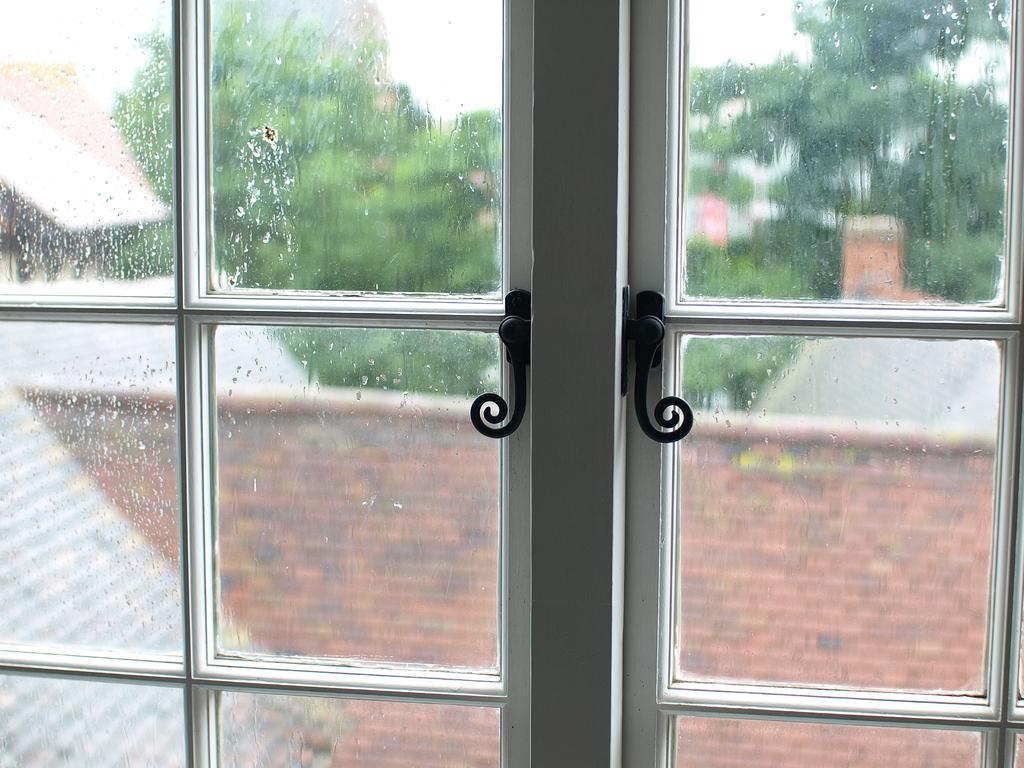Please provide a concise description of this image. In the center of the image there is a door and we can see trees, buildings and sky through the glass of a door. 